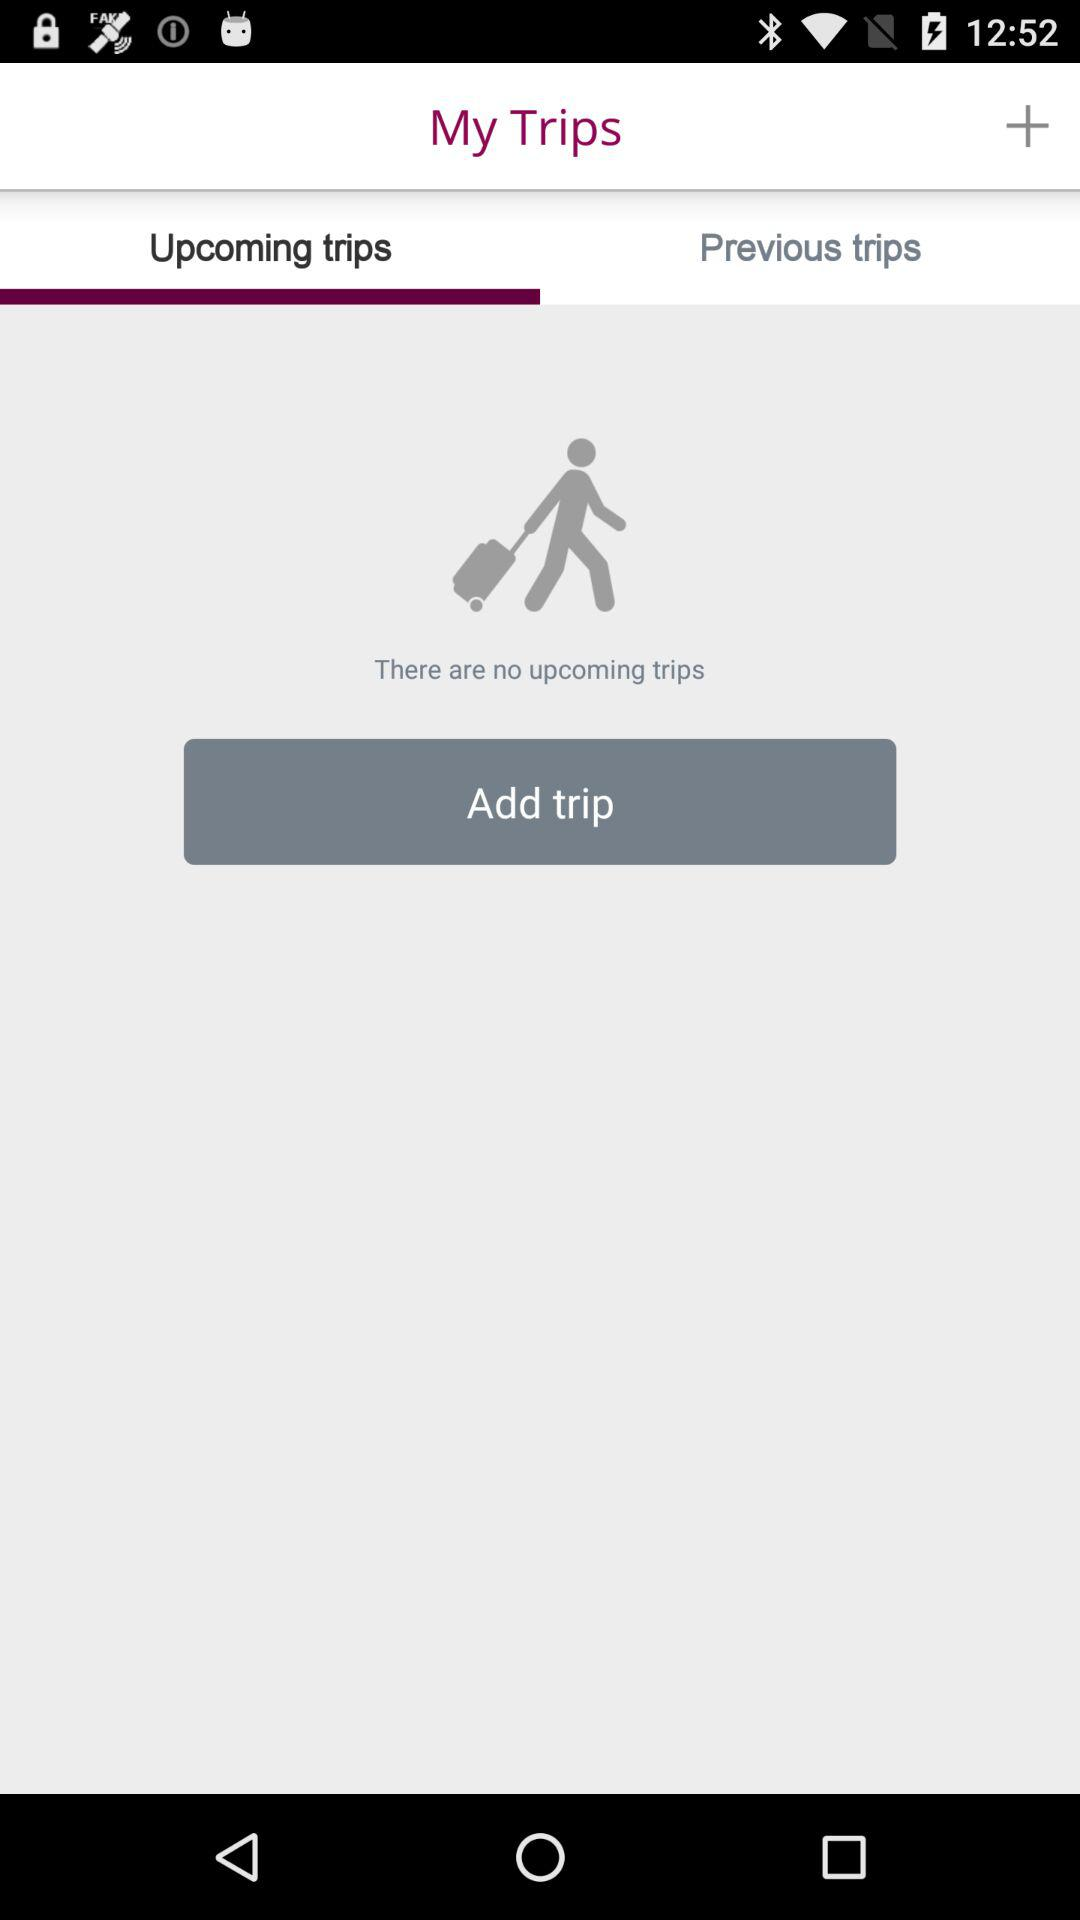Which tab is selected? The selected tab is "Upcoming trips". 